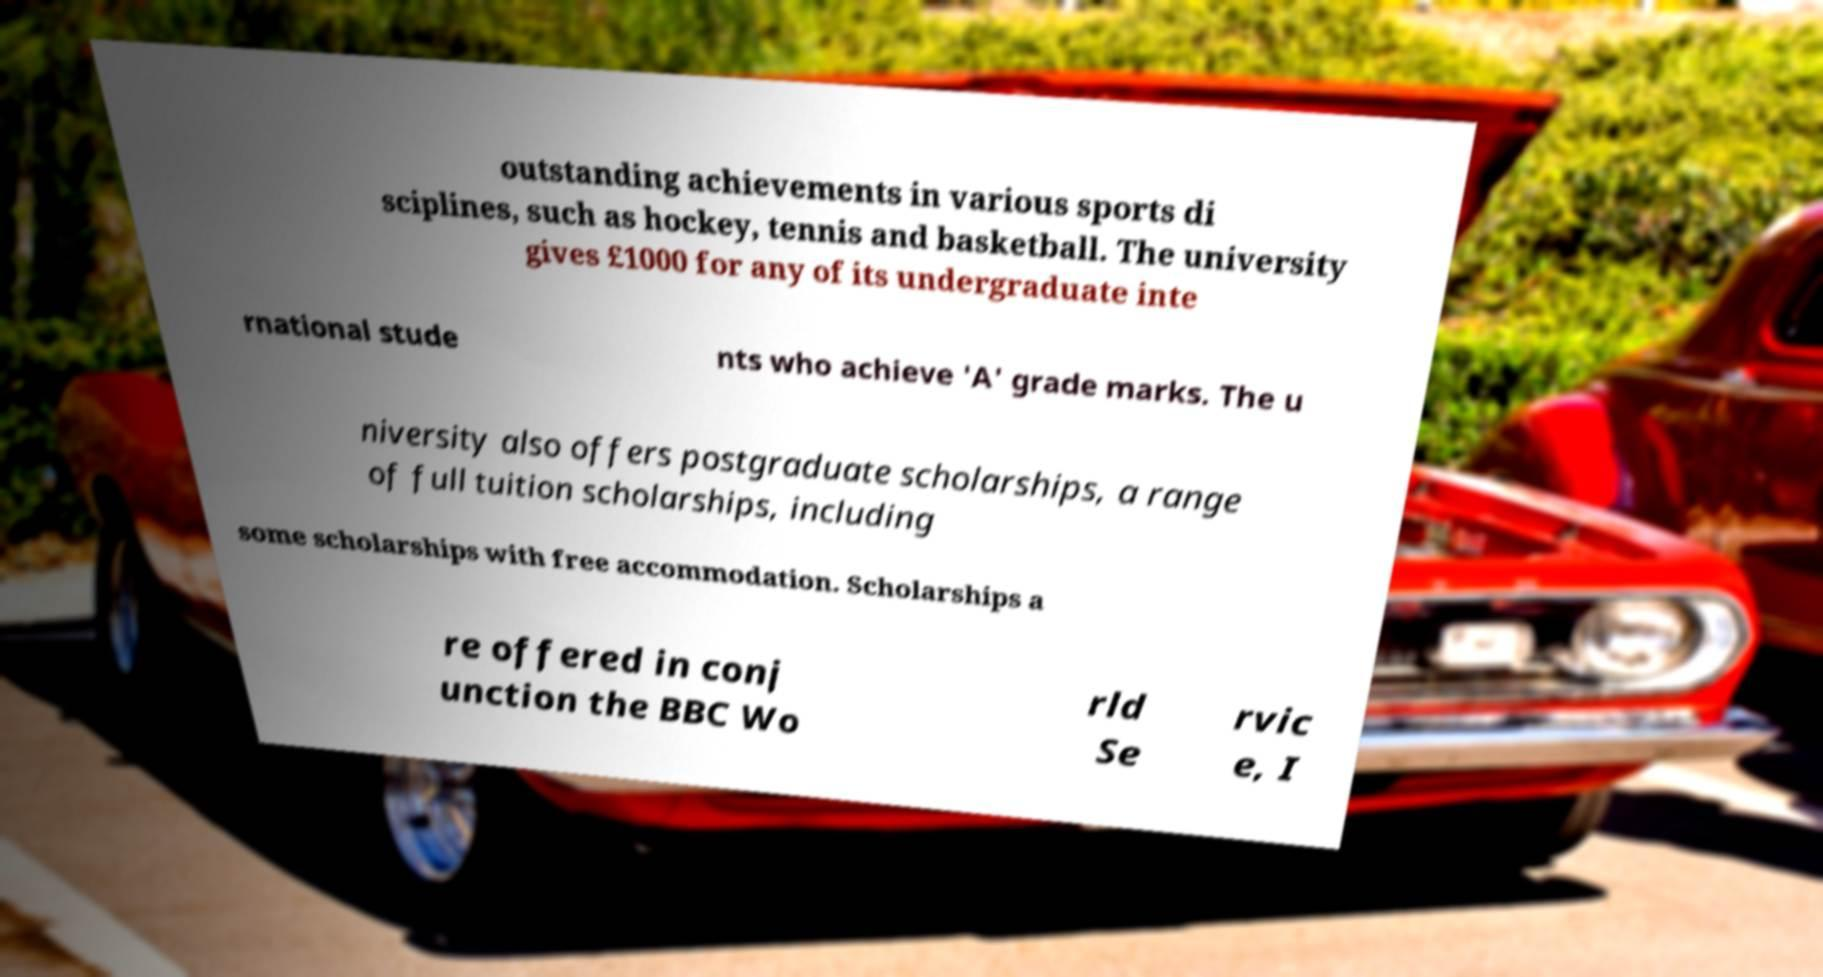Can you read and provide the text displayed in the image?This photo seems to have some interesting text. Can you extract and type it out for me? outstanding achievements in various sports di sciplines, such as hockey, tennis and basketball. The university gives £1000 for any of its undergraduate inte rnational stude nts who achieve 'A' grade marks. The u niversity also offers postgraduate scholarships, a range of full tuition scholarships, including some scholarships with free accommodation. Scholarships a re offered in conj unction the BBC Wo rld Se rvic e, I 